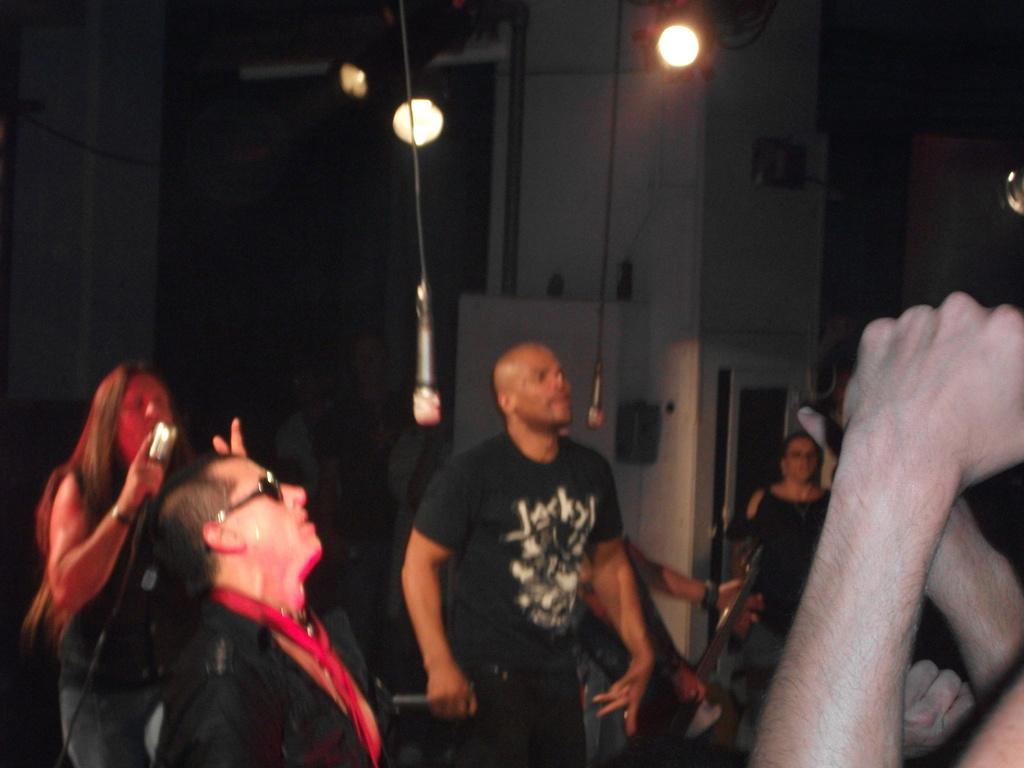How many people are in the image? There is a group of people in the image. What objects are present that are typically used for amplifying sound? There are microphones (mics) in the image. What musical instrument can be seen in the image? There is a guitar in the image. What type of lighting is present in the image? There are lights in the image. What can be said about the background of the image? The background of the image is dark. What type of thunder can be heard in the background of the image? There is no thunder present in the image; it is a group of people with microphones, a guitar, and lights in a dark background. 